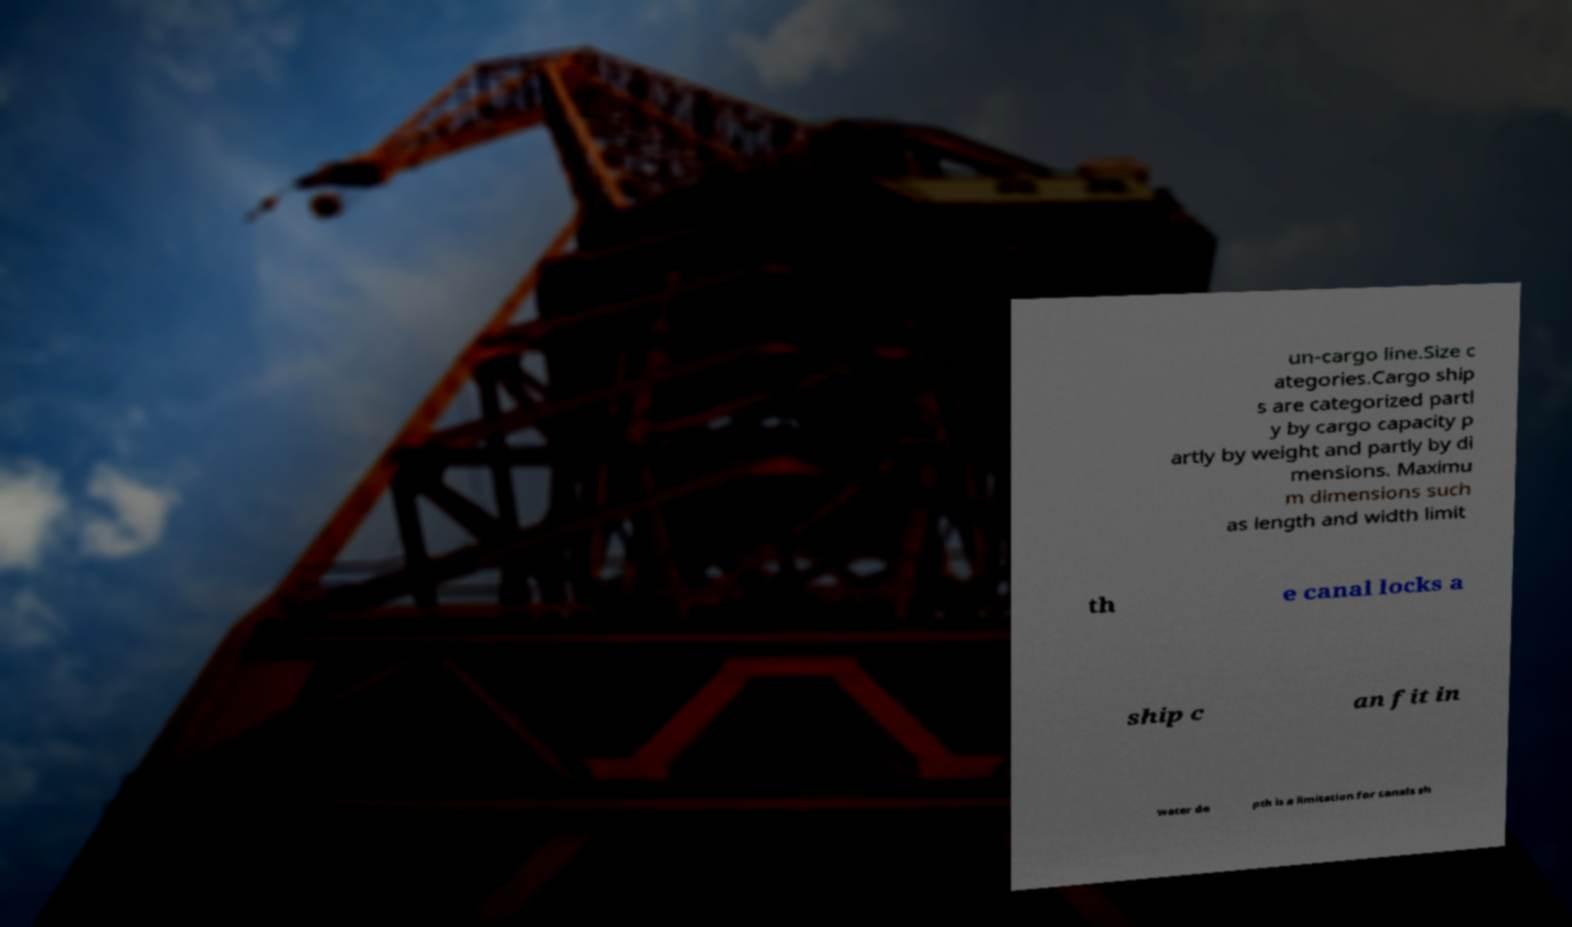There's text embedded in this image that I need extracted. Can you transcribe it verbatim? un-cargo line.Size c ategories.Cargo ship s are categorized partl y by cargo capacity p artly by weight and partly by di mensions. Maximu m dimensions such as length and width limit th e canal locks a ship c an fit in water de pth is a limitation for canals sh 